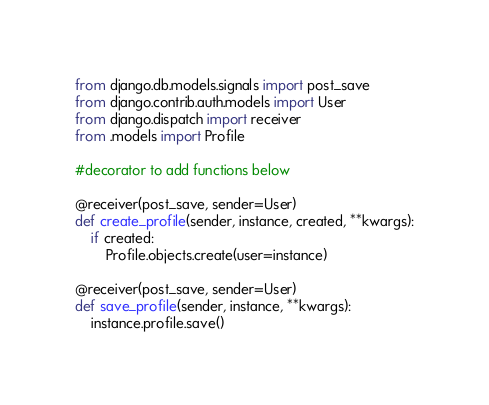<code> <loc_0><loc_0><loc_500><loc_500><_Python_>from django.db.models.signals import post_save
from django.contrib.auth.models import User
from django.dispatch import receiver
from .models import Profile

#decorator to add functions below

@receiver(post_save, sender=User)
def create_profile(sender, instance, created, **kwargs):
    if created:
        Profile.objects.create(user=instance)

@receiver(post_save, sender=User)
def save_profile(sender, instance, **kwargs):
    instance.profile.save()
</code> 